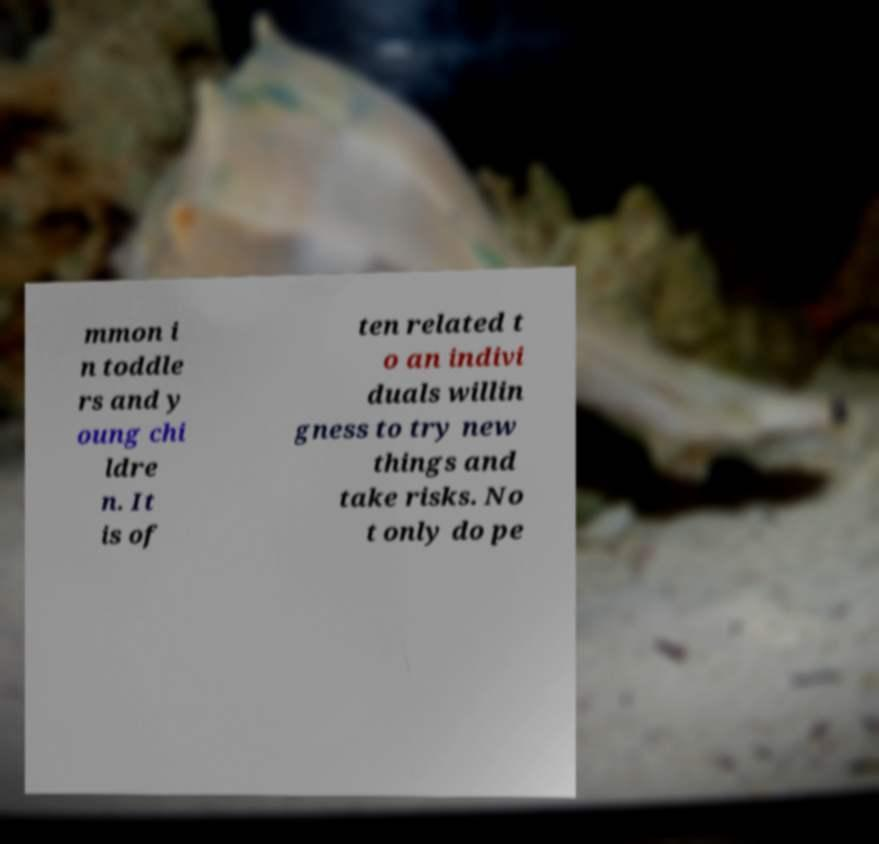I need the written content from this picture converted into text. Can you do that? mmon i n toddle rs and y oung chi ldre n. It is of ten related t o an indivi duals willin gness to try new things and take risks. No t only do pe 